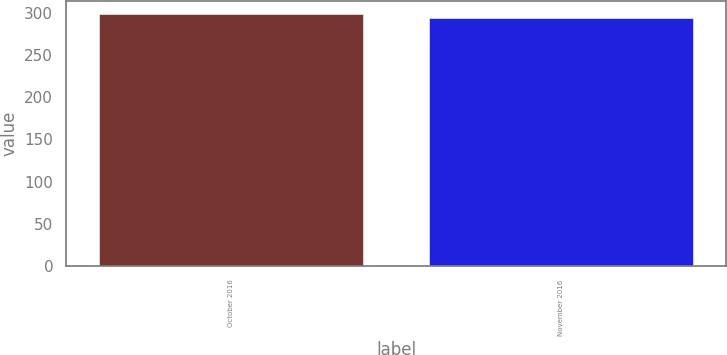<chart> <loc_0><loc_0><loc_500><loc_500><bar_chart><fcel>October 2016<fcel>November 2016<nl><fcel>298.71<fcel>294.24<nl></chart> 